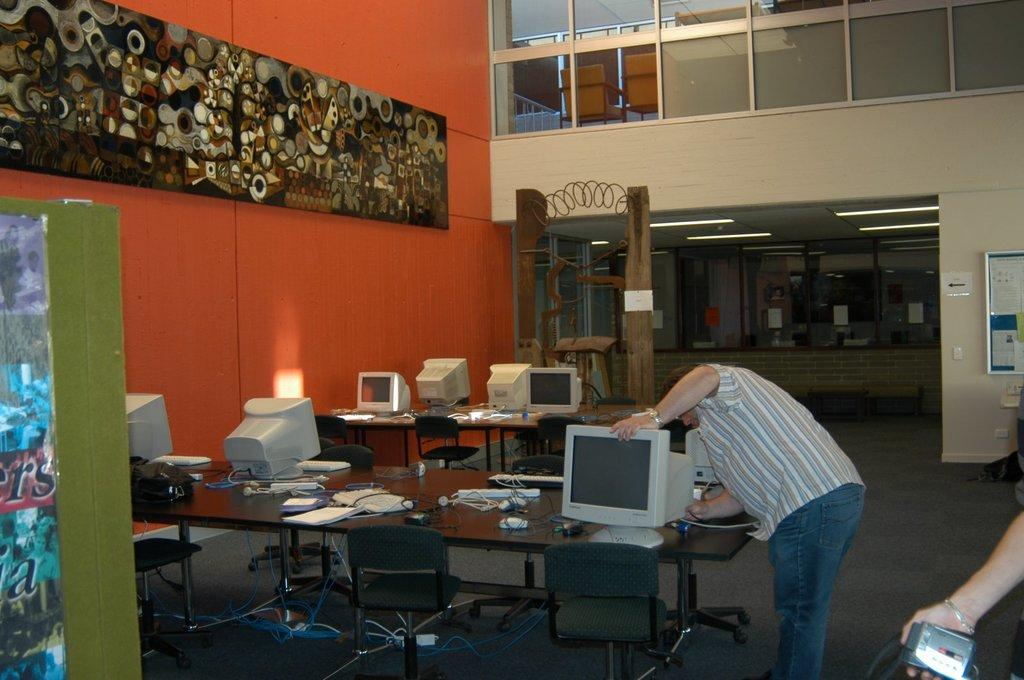What is the person in the image doing? The person is repairing a desktop in the image. How many desktops are visible on the table? There are multiple desktops on a table. What can be seen in the background of the image? There are three chairs, a wall, a light, and a window in the background. What type of lettuce is being used to fix the desktop in the image? There is no lettuce present in the image, and lettuce is not used for repairing desktops. 